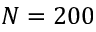<formula> <loc_0><loc_0><loc_500><loc_500>N = 2 0 0</formula> 